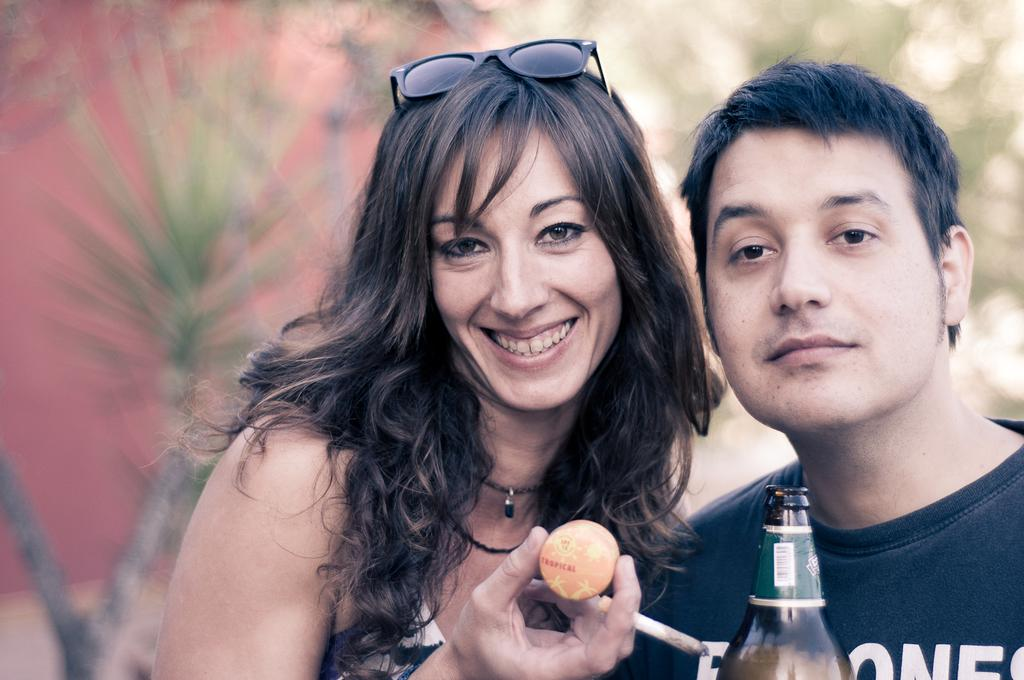How many bottles are visible in the image? There is one bottle in the image. How many people are present in the image? There are two persons in the image. What is the woman holding in the image? One woman is holding a cigarette. What type of object can be seen in the image besides the bottle and people? There is one ball in the image. What color is the wall in the background of the image? There is a pink wall in the background. What type of vegetation is visible in the background of the image? There are trees in the background. What type of blade is being used to cut the grass in the yard in the image? There is no yard or grass visible in the image, and therefore no blade can be observed. What color is the yard in the image? There is no yard present in the image, so it is not possible to determine its color. 